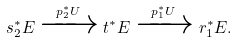<formula> <loc_0><loc_0><loc_500><loc_500>s _ { 2 } ^ { * } E \xrightarrow { p _ { 2 } ^ { * } U } t ^ { * } E \xrightarrow { p _ { 1 } ^ { * } U } r _ { 1 } ^ { * } E .</formula> 